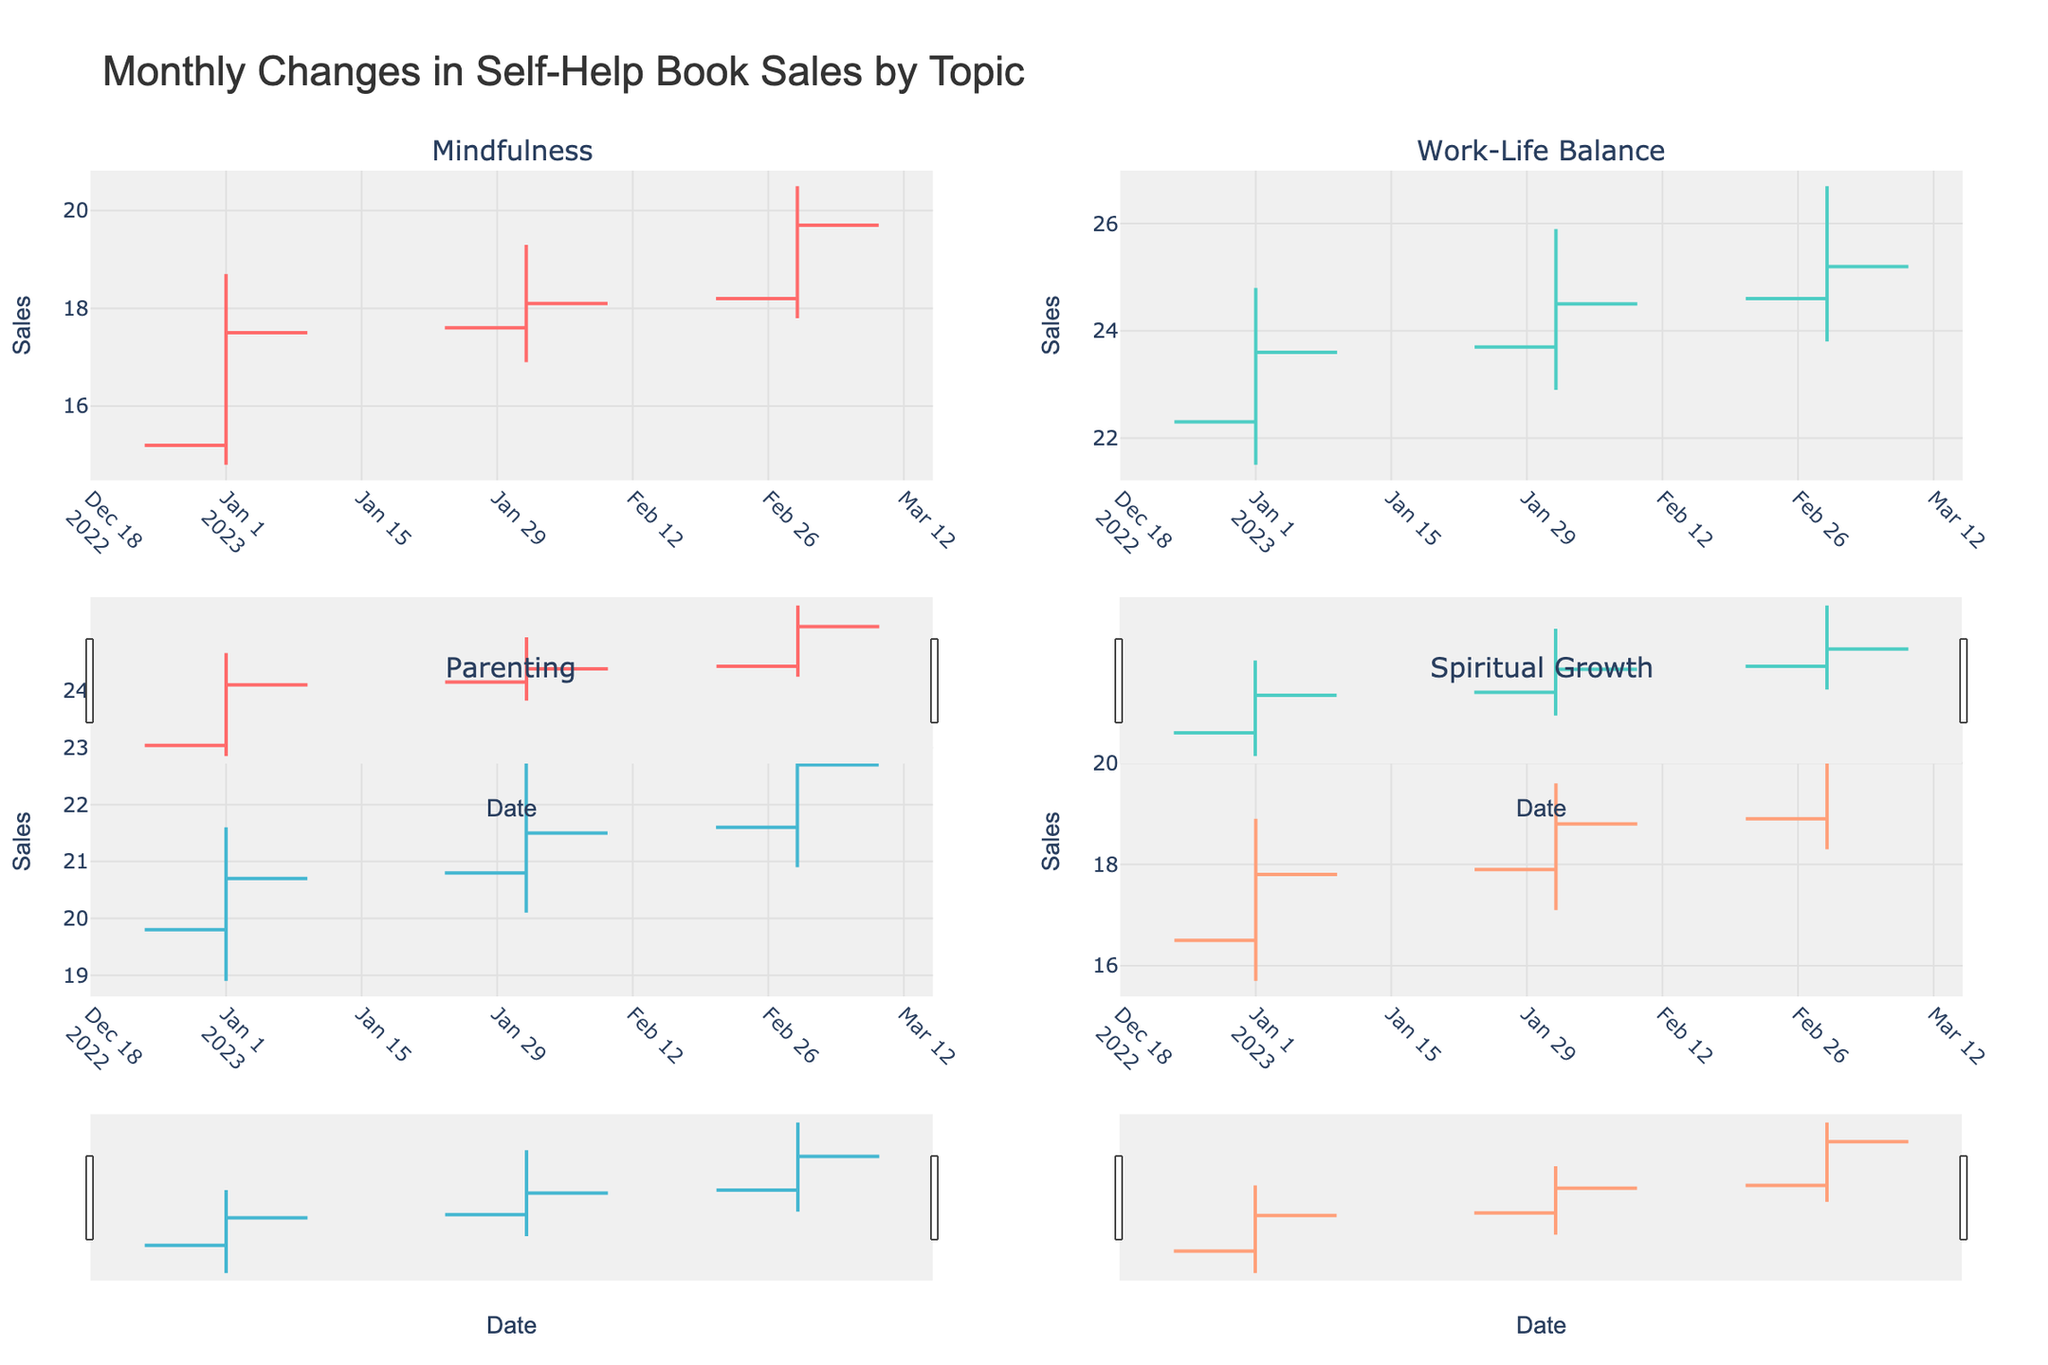What is the title of the figure? The title is prominently displayed at the top of the figure and reads 'Monthly Changes in Self-Help Book Sales by Topic'.
Answer: Monthly Changes in Self-Help Book Sales by Topic What are the topics covered in the subplots? The subplot titles indicate the topics, which are 'Mindfulness', 'Work-Life Balance', 'Parenting', and 'Spiritual Growth'.
Answer: Mindfulness, Work-Life Balance, Parenting, Spiritual Growth Which topic had the highest sales in January 2023? The 'High' value for January 2023 in each subplot must be checked. Work-Life Balance shows the highest sales with a maximum value of 24.8.
Answer: Work-Life Balance How did the 'Close' sales figure for 'Parenting' change from February to March 2023? In February, the 'Close' value for Parenting is 21.5. In March, it is 22.7. The difference is 22.7 - 21.5 = 1.2, so the sales increased.
Answer: Increased by 1.2 In which month did 'Spiritual Growth' see the highest high value? The 'High' value for each month must be compared for Spiritual Growth. The highest is 21.2 in March 2023.
Answer: March 2023 What is the average 'Open' sales figure for 'Mindfulness' over the three months? The 'Open' values for Mindfulness are 15.2, 17.6, and 18.2. The average is (15.2 + 17.6 + 18.2) / 3 = 17.
Answer: 17 Which topic had the most consistent growth over three months? By examining the 'Open' and 'Close' values month-over-month, 'Work-Life Balance' shows consistent growth where each 'Close' is higher than the previous 'Open'.
Answer: Work-Life Balance Which topic had the largest drop in 'Low' sales value in any month? Checking the 'Low' values across all months, 'Spiritual Growth' decreased from 15.7 in January to 17.1 in February and then to 18.3 in March. The largest month-to-month drop is not found but Spiritual Growth shows a trend worth noting.
Answer: No significant large drop detected Compare the 'Close' sales figures of 'Mindfulness' and 'Spiritual Growth' for March 2023. Which one is higher? For March 2023, 'Mindfulness' has a 'Close' value of 19.7, while 'Spiritual Growth' has 20.5. Comparing these, Spiritual Growth's figure is higher.
Answer: Spiritual Growth What is the difference between the highest 'High' value of 'Work-Life Balance' and 'Parenting' in March 2023? The 'High' value for Work-Life Balance in March 2023 is 26.7, and for Parenting it is 23.8. The difference is 26.7 - 23.8 = 2.9.
Answer: 2.9 